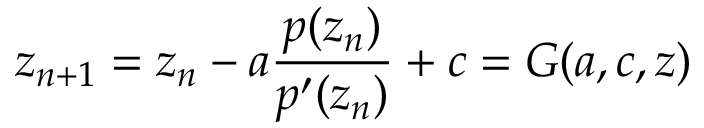Convert formula to latex. <formula><loc_0><loc_0><loc_500><loc_500>z _ { n + 1 } = z _ { n } - a { \frac { p ( z _ { n } ) } { p ^ { \prime } ( z _ { n } ) } } + c = G ( a , c , z )</formula> 